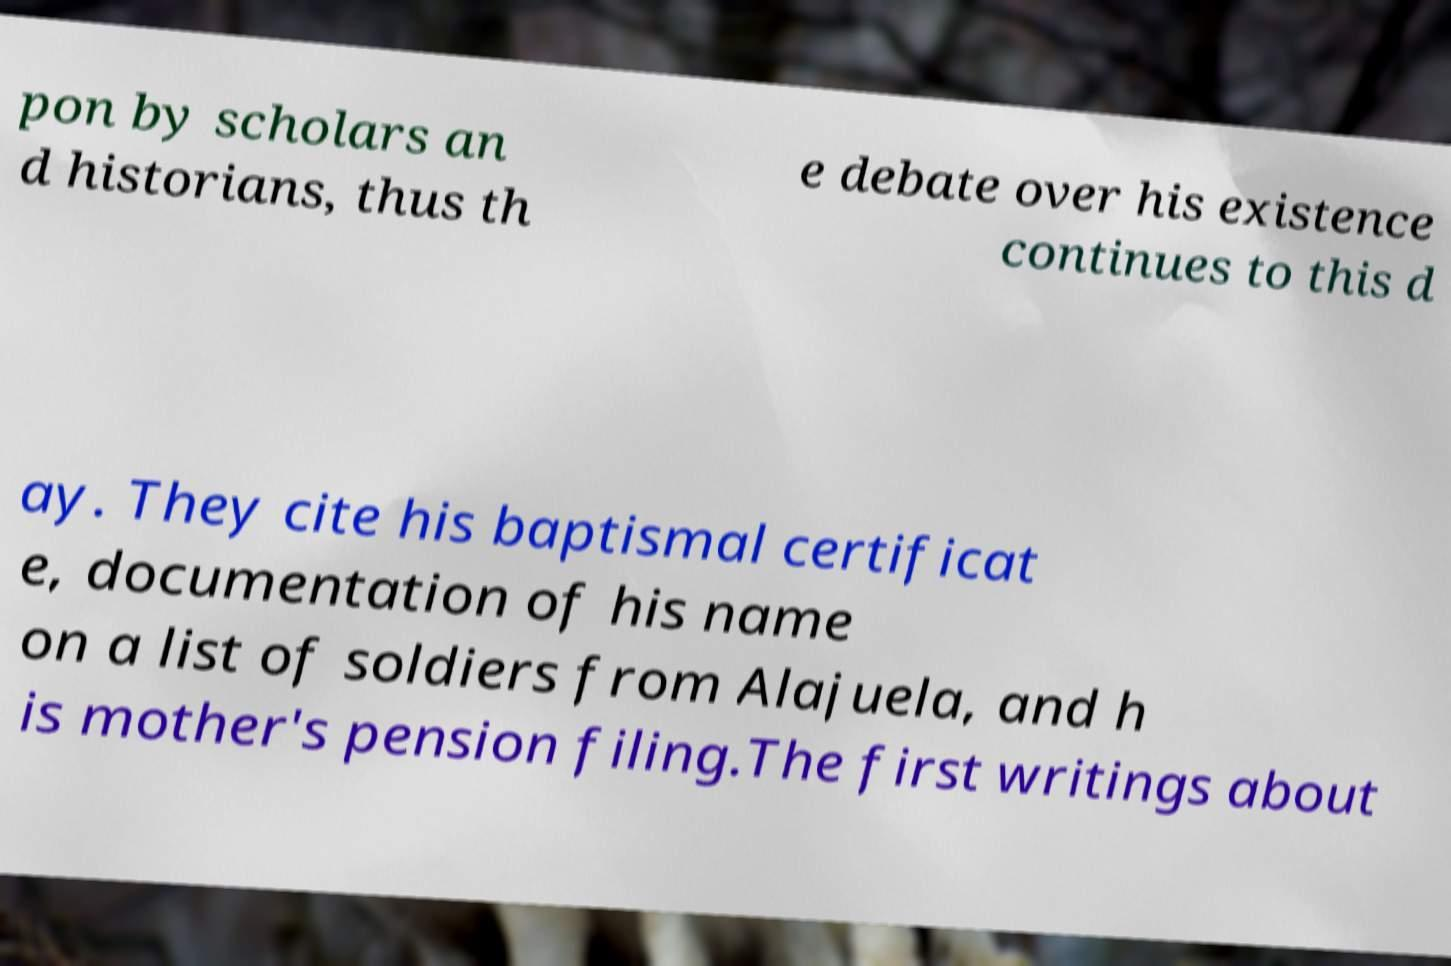Can you accurately transcribe the text from the provided image for me? pon by scholars an d historians, thus th e debate over his existence continues to this d ay. They cite his baptismal certificat e, documentation of his name on a list of soldiers from Alajuela, and h is mother's pension filing.The first writings about 